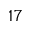Convert formula to latex. <formula><loc_0><loc_0><loc_500><loc_500>^ { 1 7 }</formula> 